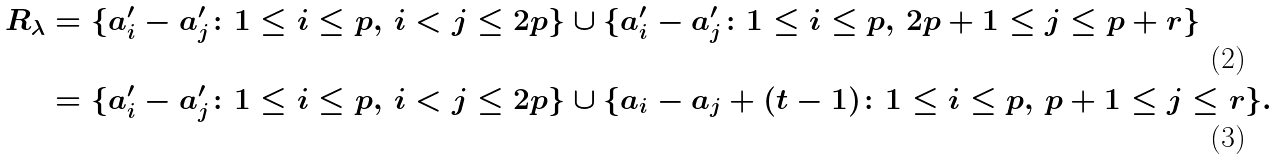Convert formula to latex. <formula><loc_0><loc_0><loc_500><loc_500>R _ { \lambda } & = \{ a _ { i } ^ { \prime } - a _ { j } ^ { \prime } \colon 1 \leq i \leq p , \, i < j \leq 2 p \} \cup \{ a _ { i } ^ { \prime } - a _ { j } ^ { \prime } \colon 1 \leq i \leq p , \, 2 p + 1 \leq j \leq p + r \} \\ & = \{ a _ { i } ^ { \prime } - a _ { j } ^ { \prime } \colon 1 \leq i \leq p , \, i < j \leq 2 p \} \cup \{ a _ { i } - a _ { j } + ( t - 1 ) \colon 1 \leq i \leq p , \, p + 1 \leq j \leq r \} .</formula> 